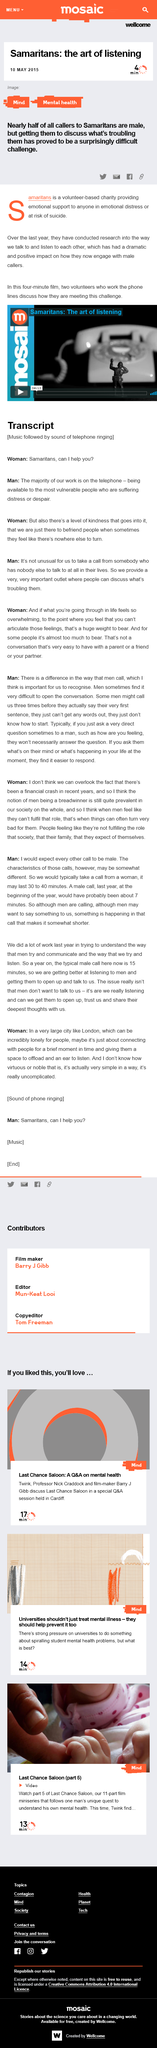Specify some key components in this picture. The majority of the Samaritans' work takes place over the phone. The film is shown for a duration of 4 minutes. Almost 50% of callers to the Samaritans are male. This page is a transcript of a telephone call that provides information about the topic. The article is about the Samaritans, an organization that is mentioned in the text. 